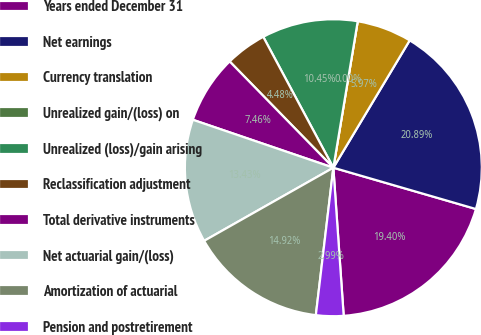Convert chart. <chart><loc_0><loc_0><loc_500><loc_500><pie_chart><fcel>Years ended December 31<fcel>Net earnings<fcel>Currency translation<fcel>Unrealized gain/(loss) on<fcel>Unrealized (loss)/gain arising<fcel>Reclassification adjustment<fcel>Total derivative instruments<fcel>Net actuarial gain/(loss)<fcel>Amortization of actuarial<fcel>Pension and postretirement<nl><fcel>19.4%<fcel>20.89%<fcel>5.97%<fcel>0.0%<fcel>10.45%<fcel>4.48%<fcel>7.46%<fcel>13.43%<fcel>14.92%<fcel>2.99%<nl></chart> 